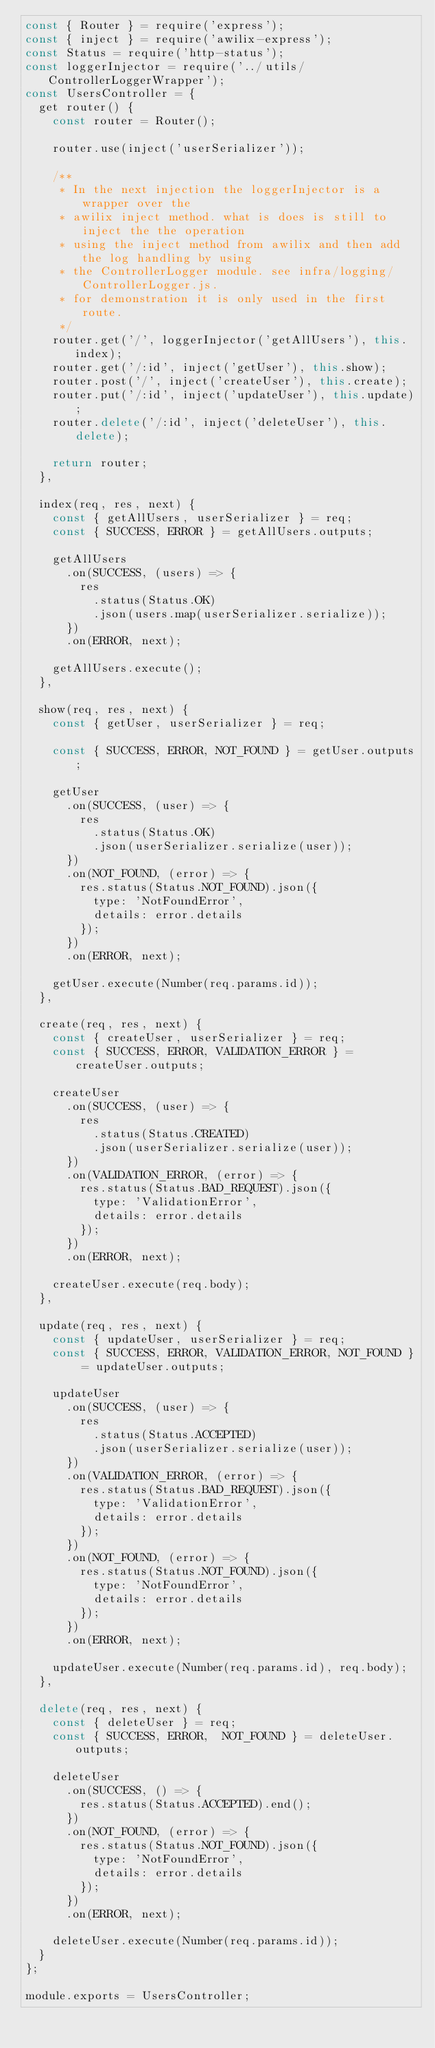Convert code to text. <code><loc_0><loc_0><loc_500><loc_500><_JavaScript_>const { Router } = require('express');
const { inject } = require('awilix-express');
const Status = require('http-status');
const loggerInjector = require('../utils/ControllerLoggerWrapper');
const UsersController = {
  get router() {
    const router = Router();

    router.use(inject('userSerializer'));

    /**
     * In the next injection the loggerInjector is a wrapper over the
     * awilix inject method. what is does is still to inject the the operation
     * using the inject method from awilix and then add the log handling by using
     * the ControllerLogger module. see infra/logging/ControllerLogger.js.
     * for demonstration it is only used in the first route.
     */
    router.get('/', loggerInjector('getAllUsers'), this.index);
    router.get('/:id', inject('getUser'), this.show);
    router.post('/', inject('createUser'), this.create);
    router.put('/:id', inject('updateUser'), this.update);
    router.delete('/:id', inject('deleteUser'), this.delete);

    return router;
  },

  index(req, res, next) {
    const { getAllUsers, userSerializer } = req;
    const { SUCCESS, ERROR } = getAllUsers.outputs;

    getAllUsers
      .on(SUCCESS, (users) => {
        res
          .status(Status.OK)
          .json(users.map(userSerializer.serialize));
      })
      .on(ERROR, next);

    getAllUsers.execute();
  },

  show(req, res, next) {
    const { getUser, userSerializer } = req;

    const { SUCCESS, ERROR, NOT_FOUND } = getUser.outputs;

    getUser
      .on(SUCCESS, (user) => {
        res
          .status(Status.OK)
          .json(userSerializer.serialize(user));
      })
      .on(NOT_FOUND, (error) => {
        res.status(Status.NOT_FOUND).json({
          type: 'NotFoundError',
          details: error.details
        });
      })
      .on(ERROR, next);

    getUser.execute(Number(req.params.id));
  },

  create(req, res, next) {
    const { createUser, userSerializer } = req;
    const { SUCCESS, ERROR, VALIDATION_ERROR } = createUser.outputs;

    createUser
      .on(SUCCESS, (user) => {
        res
          .status(Status.CREATED)
          .json(userSerializer.serialize(user));
      })
      .on(VALIDATION_ERROR, (error) => {
        res.status(Status.BAD_REQUEST).json({
          type: 'ValidationError',
          details: error.details
        });
      })
      .on(ERROR, next);

    createUser.execute(req.body);
  },

  update(req, res, next) {
    const { updateUser, userSerializer } = req;
    const { SUCCESS, ERROR, VALIDATION_ERROR, NOT_FOUND } = updateUser.outputs;

    updateUser
      .on(SUCCESS, (user) => {
        res
          .status(Status.ACCEPTED)
          .json(userSerializer.serialize(user));
      })
      .on(VALIDATION_ERROR, (error) => {
        res.status(Status.BAD_REQUEST).json({
          type: 'ValidationError',
          details: error.details
        });
      })
      .on(NOT_FOUND, (error) => {
        res.status(Status.NOT_FOUND).json({
          type: 'NotFoundError',
          details: error.details
        });
      })
      .on(ERROR, next);

    updateUser.execute(Number(req.params.id), req.body);
  },

  delete(req, res, next) {
    const { deleteUser } = req;
    const { SUCCESS, ERROR,  NOT_FOUND } = deleteUser.outputs;

    deleteUser
      .on(SUCCESS, () => {
        res.status(Status.ACCEPTED).end();
      })
      .on(NOT_FOUND, (error) => {
        res.status(Status.NOT_FOUND).json({
          type: 'NotFoundError',
          details: error.details
        });
      })
      .on(ERROR, next);

    deleteUser.execute(Number(req.params.id));
  }
};

module.exports = UsersController;
</code> 